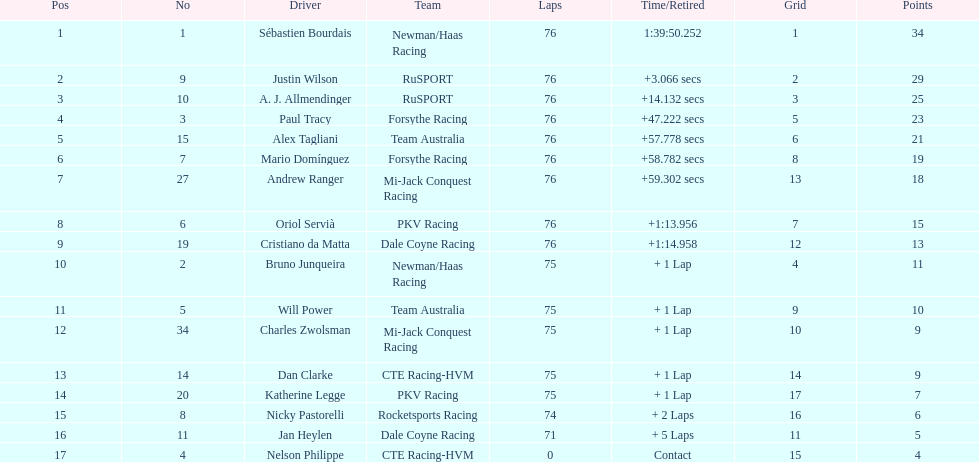Who was the first to finish among canadian drivers: alex tagliani or paul tracy? Paul Tracy. 